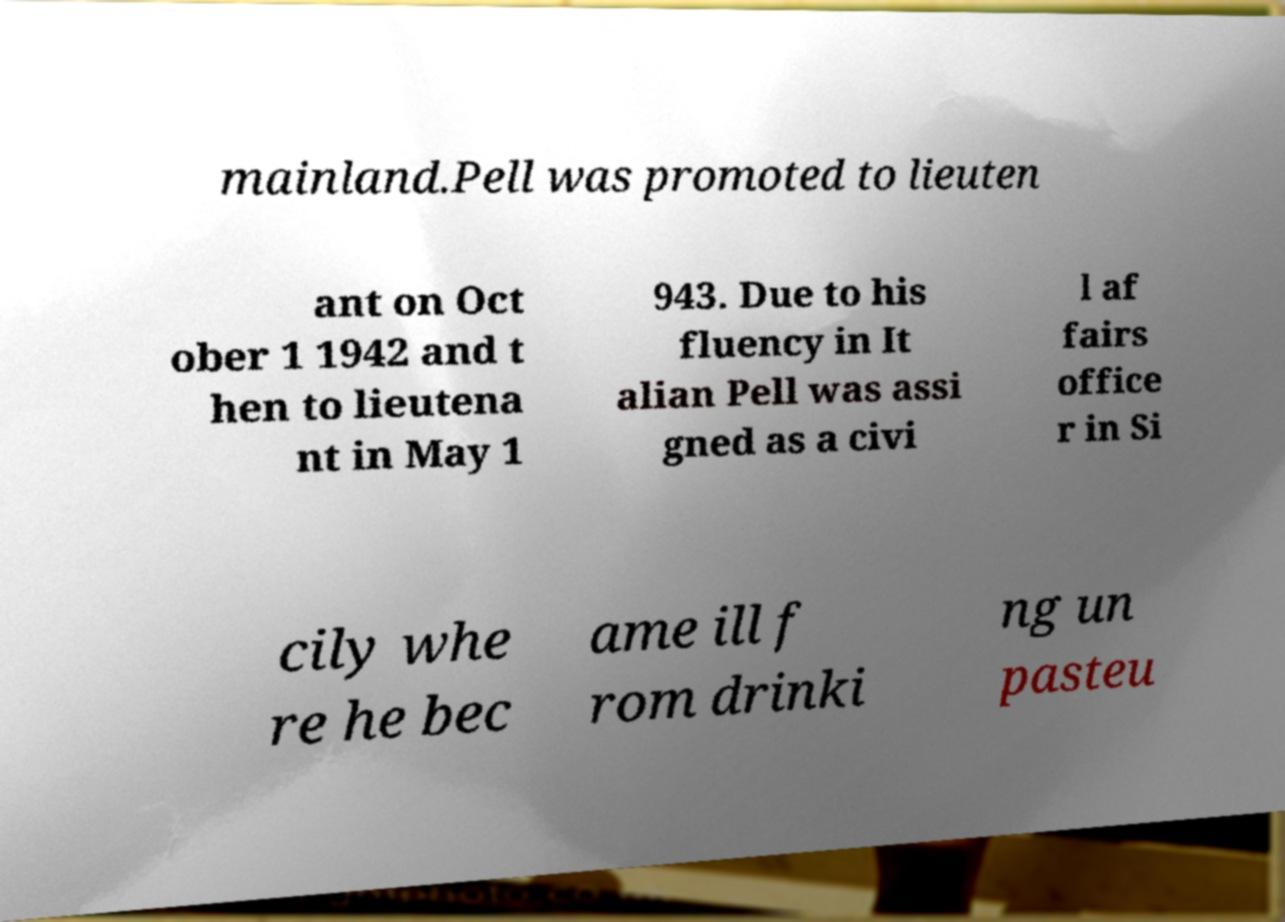Could you assist in decoding the text presented in this image and type it out clearly? mainland.Pell was promoted to lieuten ant on Oct ober 1 1942 and t hen to lieutena nt in May 1 943. Due to his fluency in It alian Pell was assi gned as a civi l af fairs office r in Si cily whe re he bec ame ill f rom drinki ng un pasteu 